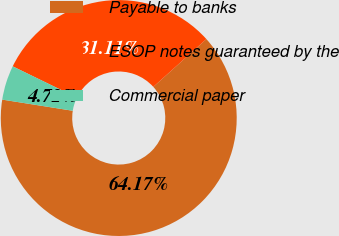Convert chart to OTSL. <chart><loc_0><loc_0><loc_500><loc_500><pie_chart><fcel>Payable to banks<fcel>ESOP notes guaranteed by the<fcel>Commercial paper<nl><fcel>64.17%<fcel>31.11%<fcel>4.72%<nl></chart> 